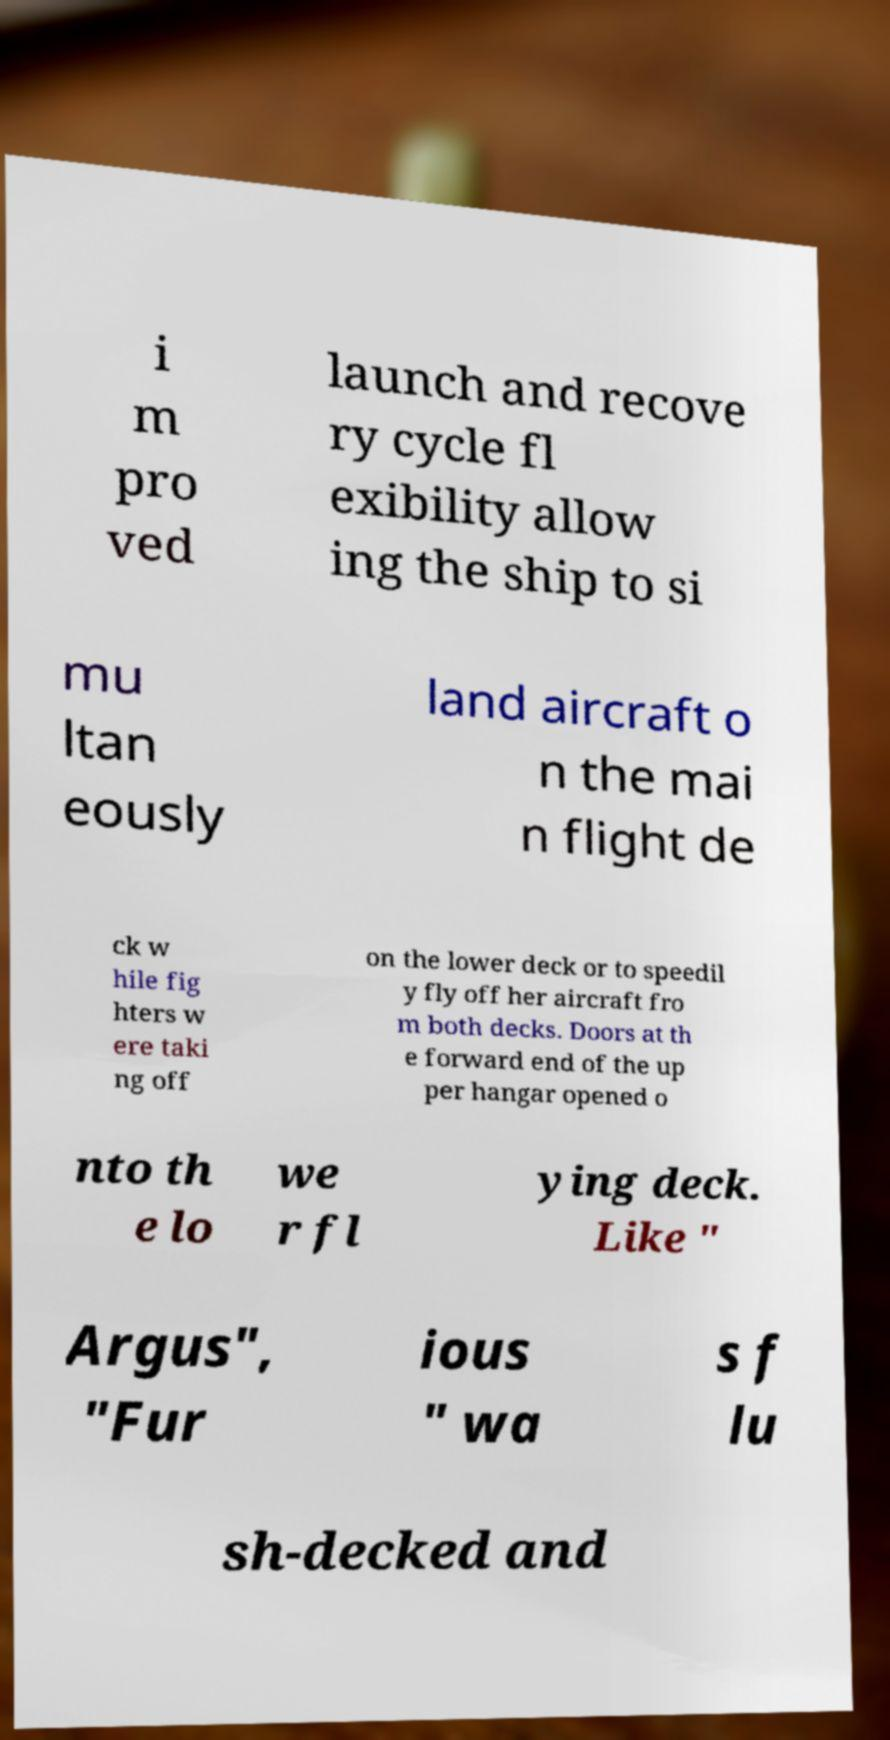Please read and relay the text visible in this image. What does it say? i m pro ved launch and recove ry cycle fl exibility allow ing the ship to si mu ltan eously land aircraft o n the mai n flight de ck w hile fig hters w ere taki ng off on the lower deck or to speedil y fly off her aircraft fro m both decks. Doors at th e forward end of the up per hangar opened o nto th e lo we r fl ying deck. Like " Argus", "Fur ious " wa s f lu sh-decked and 